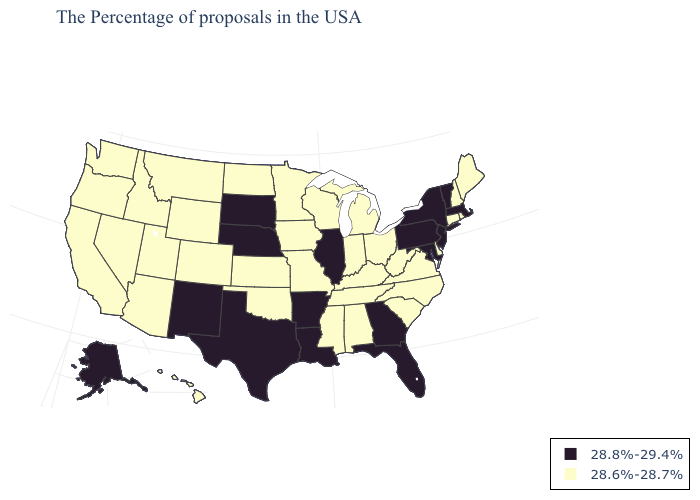Name the states that have a value in the range 28.6%-28.7%?
Concise answer only. Maine, Rhode Island, New Hampshire, Connecticut, Delaware, Virginia, North Carolina, South Carolina, West Virginia, Ohio, Michigan, Kentucky, Indiana, Alabama, Tennessee, Wisconsin, Mississippi, Missouri, Minnesota, Iowa, Kansas, Oklahoma, North Dakota, Wyoming, Colorado, Utah, Montana, Arizona, Idaho, Nevada, California, Washington, Oregon, Hawaii. How many symbols are there in the legend?
Quick response, please. 2. Among the states that border Iowa , which have the highest value?
Concise answer only. Illinois, Nebraska, South Dakota. Name the states that have a value in the range 28.8%-29.4%?
Keep it brief. Massachusetts, Vermont, New York, New Jersey, Maryland, Pennsylvania, Florida, Georgia, Illinois, Louisiana, Arkansas, Nebraska, Texas, South Dakota, New Mexico, Alaska. What is the lowest value in the USA?
Concise answer only. 28.6%-28.7%. What is the value of Virginia?
Keep it brief. 28.6%-28.7%. What is the value of Connecticut?
Quick response, please. 28.6%-28.7%. Among the states that border Tennessee , does Arkansas have the highest value?
Give a very brief answer. Yes. How many symbols are there in the legend?
Be succinct. 2. What is the value of North Carolina?
Short answer required. 28.6%-28.7%. Among the states that border Texas , does Oklahoma have the highest value?
Be succinct. No. What is the value of Kentucky?
Quick response, please. 28.6%-28.7%. Name the states that have a value in the range 28.8%-29.4%?
Short answer required. Massachusetts, Vermont, New York, New Jersey, Maryland, Pennsylvania, Florida, Georgia, Illinois, Louisiana, Arkansas, Nebraska, Texas, South Dakota, New Mexico, Alaska. Name the states that have a value in the range 28.8%-29.4%?
Quick response, please. Massachusetts, Vermont, New York, New Jersey, Maryland, Pennsylvania, Florida, Georgia, Illinois, Louisiana, Arkansas, Nebraska, Texas, South Dakota, New Mexico, Alaska. What is the value of Connecticut?
Short answer required. 28.6%-28.7%. 